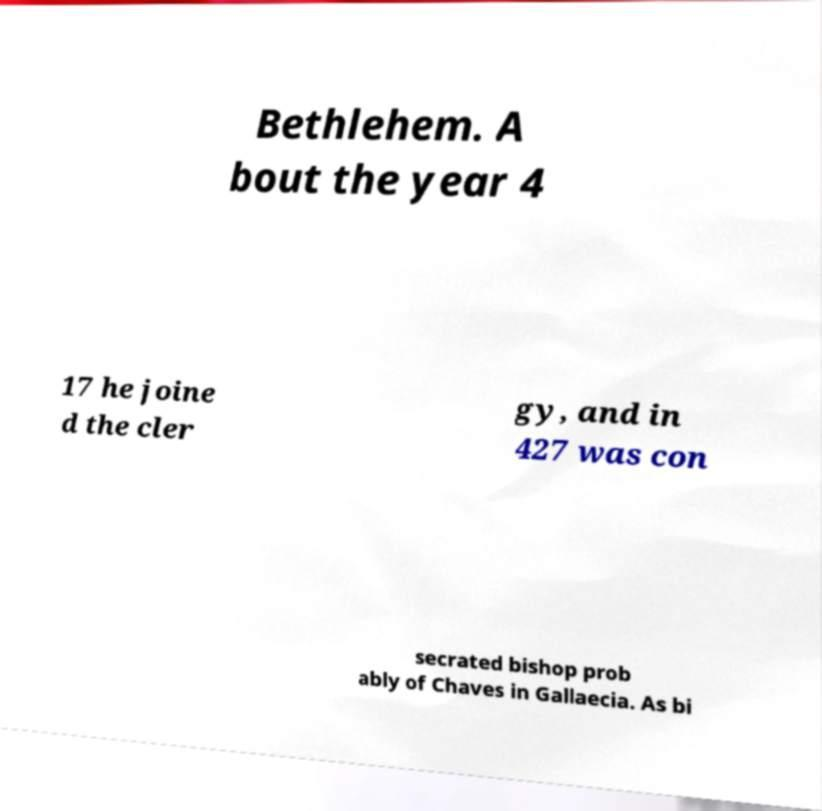For documentation purposes, I need the text within this image transcribed. Could you provide that? Bethlehem. A bout the year 4 17 he joine d the cler gy, and in 427 was con secrated bishop prob ably of Chaves in Gallaecia. As bi 